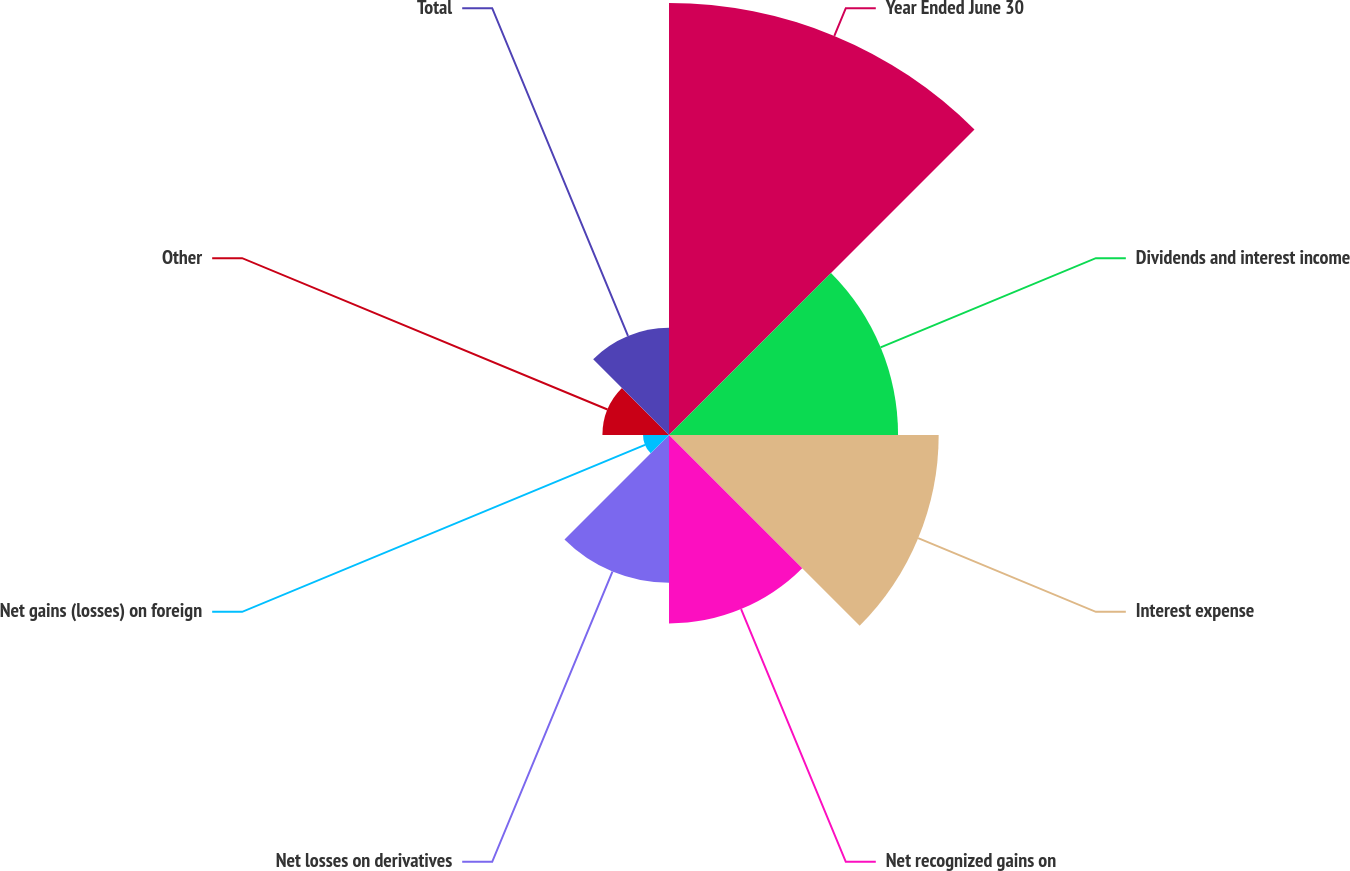Convert chart. <chart><loc_0><loc_0><loc_500><loc_500><pie_chart><fcel>Year Ended June 30<fcel>Dividends and interest income<fcel>Interest expense<fcel>Net recognized gains on<fcel>Net losses on derivatives<fcel>Net gains (losses) on foreign<fcel>Other<fcel>Total<nl><fcel>29.46%<fcel>15.62%<fcel>18.39%<fcel>12.85%<fcel>10.08%<fcel>1.77%<fcel>4.54%<fcel>7.31%<nl></chart> 